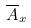<formula> <loc_0><loc_0><loc_500><loc_500>\overline { A } _ { x }</formula> 